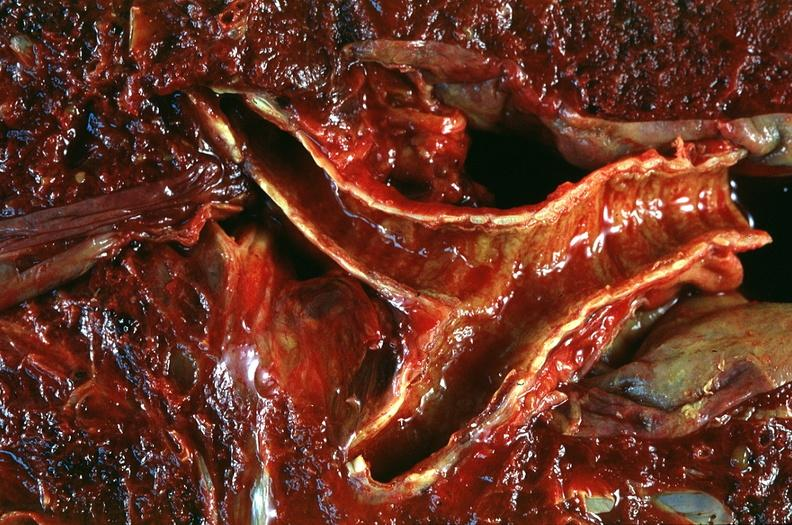how many antitrypsin does this image show lung, emphysema and bronchial hemorrhage, alpha-deficiency?
Answer the question using a single word or phrase. 1 